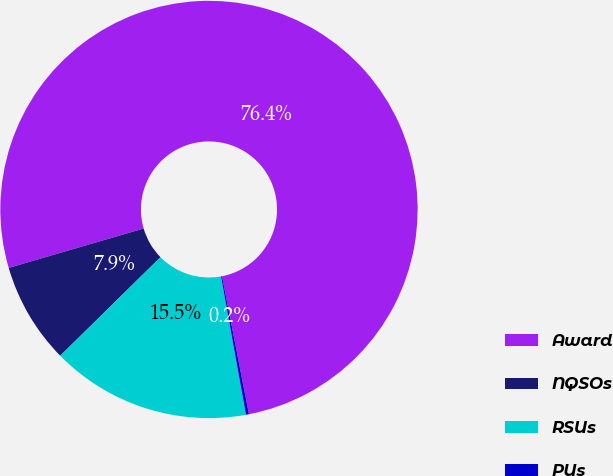Convert chart to OTSL. <chart><loc_0><loc_0><loc_500><loc_500><pie_chart><fcel>Award<fcel>NQSOs<fcel>RSUs<fcel>PUs<nl><fcel>76.45%<fcel>7.85%<fcel>15.47%<fcel>0.23%<nl></chart> 